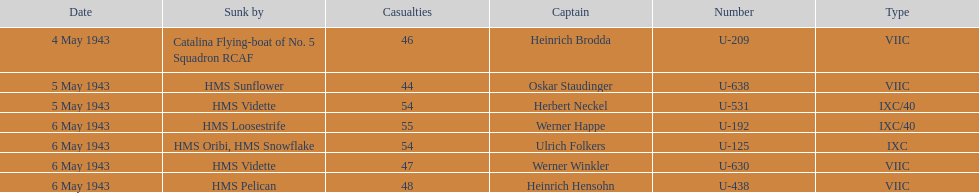Which sunken u-boat had the most casualties U-192. 